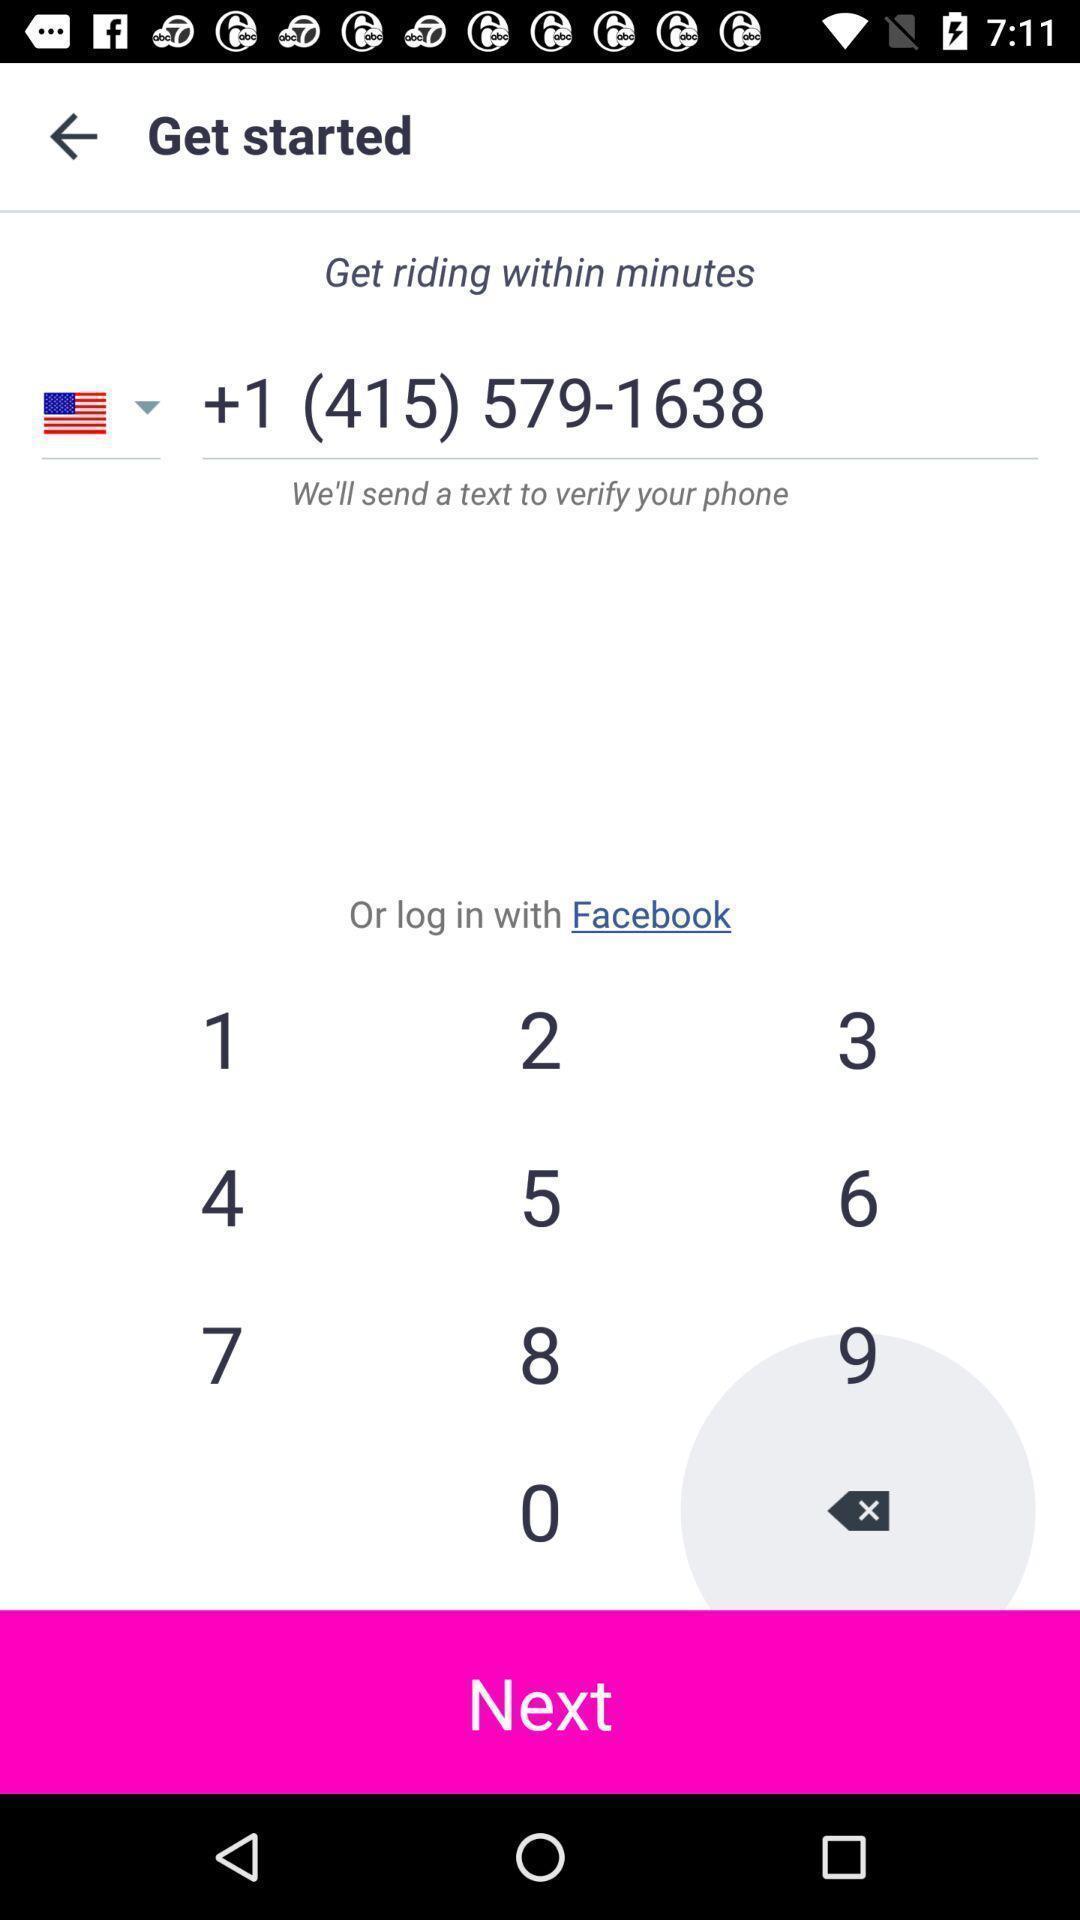Describe the content in this image. Page displaying information about a car ride application. 